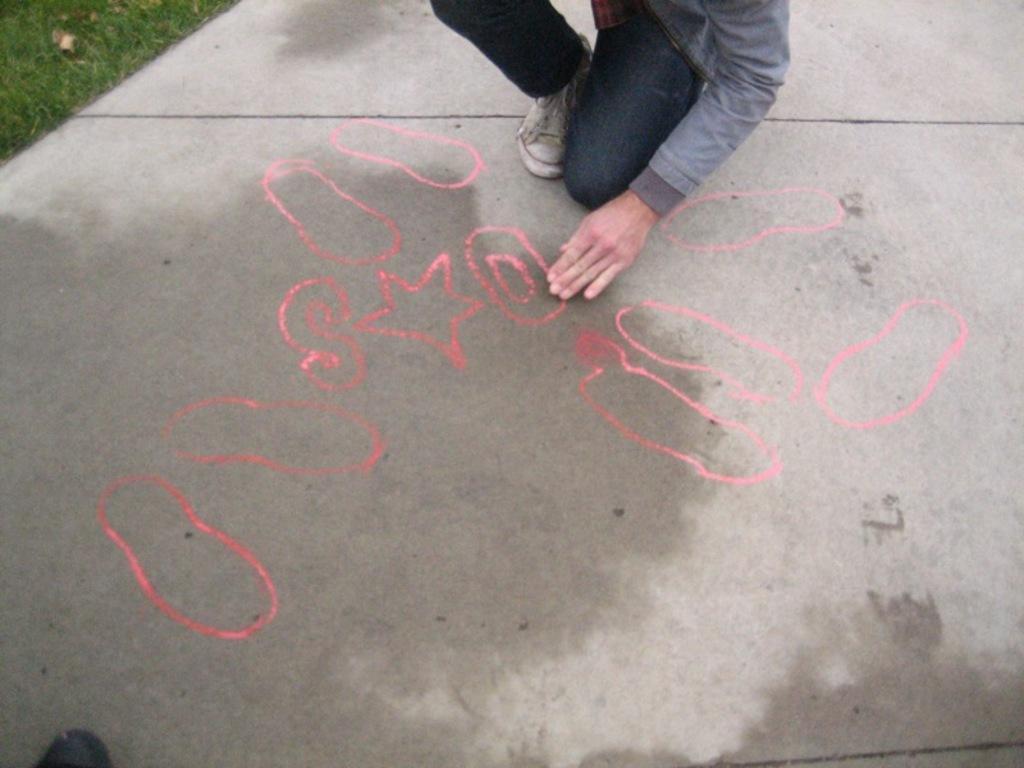In one or two sentences, can you explain what this image depicts? In the image on the floor there are few drawings. At the top of the image there is a person with grey jacket, blue jeans and white shoes. At the left top corner of the image there is grass. 